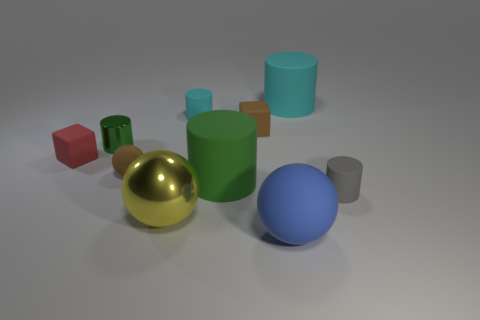Is the number of large green matte cylinders left of the small cyan rubber object greater than the number of big yellow matte cylinders?
Provide a short and direct response. No. The large matte thing in front of the small object in front of the green cylinder that is in front of the red matte thing is what shape?
Give a very brief answer. Sphere. Is the shape of the small brown thing behind the small green metallic cylinder the same as the tiny brown thing in front of the metallic cylinder?
Offer a very short reply. No. Is there any other thing that is the same size as the gray object?
Keep it short and to the point. Yes. What number of balls are either blue objects or small blue objects?
Your answer should be very brief. 1. Is the material of the large yellow thing the same as the red block?
Provide a short and direct response. No. What number of other things are the same color as the tiny matte ball?
Your answer should be compact. 1. What is the shape of the tiny brown thing in front of the tiny metallic thing?
Provide a short and direct response. Sphere. How many objects are either big cyan cubes or large green rubber objects?
Your answer should be very brief. 1. There is a metallic sphere; is it the same size as the matte cube right of the large yellow ball?
Keep it short and to the point. No. 